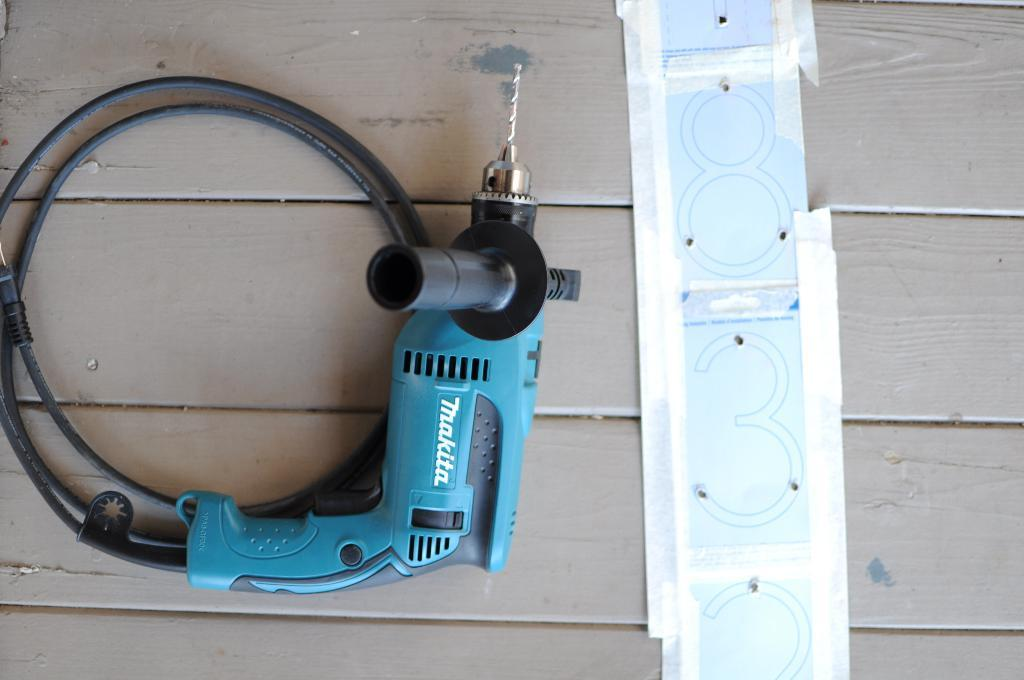What is the main subject of the image? The main subject of the image is a drilling machine. Can you describe the secondary object in the image? There is an object on a wooden plank in the image. How many boys are playing with the horse in the image? There are no boys or horses present in the image. 